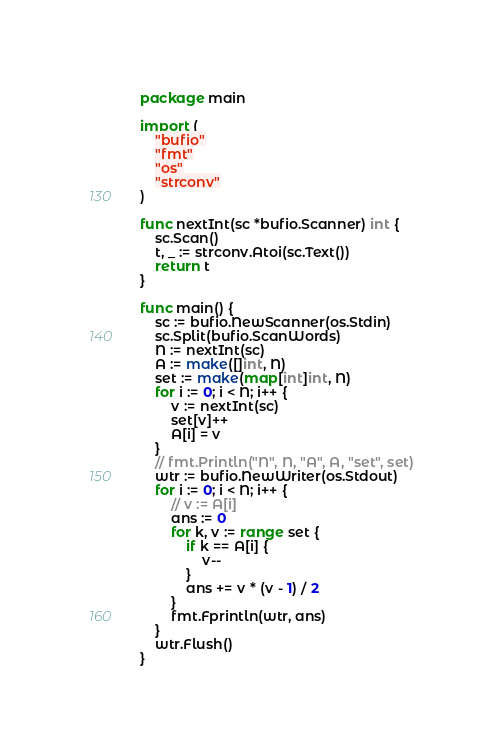<code> <loc_0><loc_0><loc_500><loc_500><_Go_>package main

import (
	"bufio"
	"fmt"
	"os"
	"strconv"
)

func nextInt(sc *bufio.Scanner) int {
	sc.Scan()
	t, _ := strconv.Atoi(sc.Text())
	return t
}

func main() {
	sc := bufio.NewScanner(os.Stdin)
	sc.Split(bufio.ScanWords)
	N := nextInt(sc)
	A := make([]int, N)
	set := make(map[int]int, N)
	for i := 0; i < N; i++ {
		v := nextInt(sc)
		set[v]++
		A[i] = v
	}
	// fmt.Println("N", N, "A", A, "set", set)
	wtr := bufio.NewWriter(os.Stdout)
	for i := 0; i < N; i++ {
		// v := A[i]
		ans := 0
		for k, v := range set {
			if k == A[i] {
				v--
			}
			ans += v * (v - 1) / 2
		}
		fmt.Fprintln(wtr, ans)
	}
	wtr.Flush()
}
</code> 